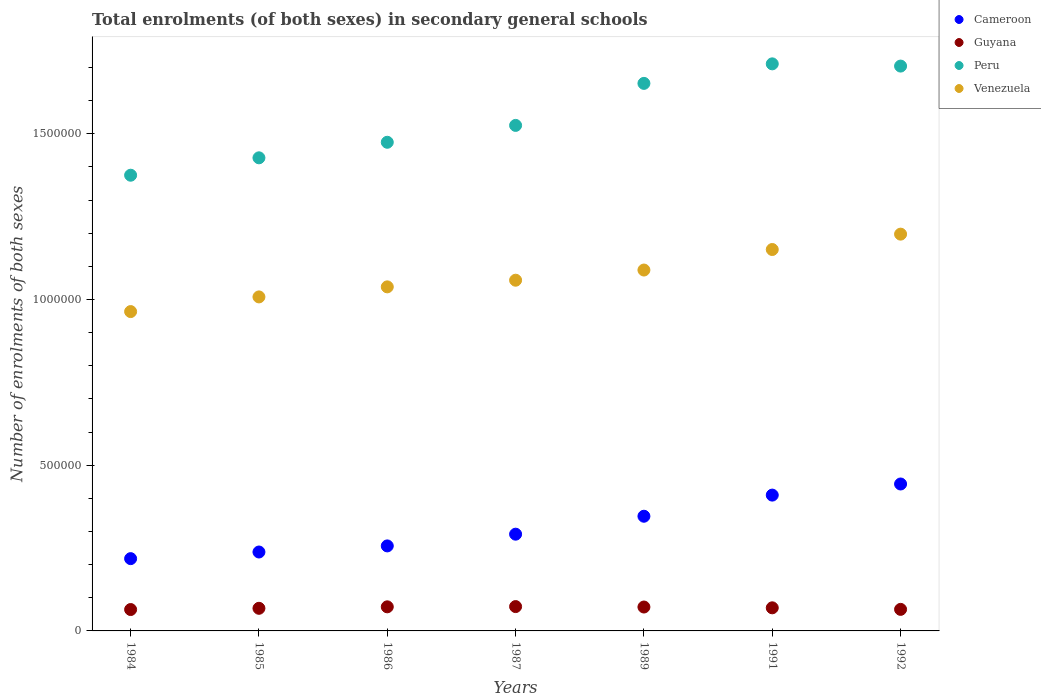What is the number of enrolments in secondary schools in Cameroon in 1989?
Keep it short and to the point. 3.46e+05. Across all years, what is the maximum number of enrolments in secondary schools in Cameroon?
Offer a very short reply. 4.43e+05. Across all years, what is the minimum number of enrolments in secondary schools in Venezuela?
Keep it short and to the point. 9.63e+05. In which year was the number of enrolments in secondary schools in Cameroon maximum?
Your response must be concise. 1992. What is the total number of enrolments in secondary schools in Guyana in the graph?
Your answer should be compact. 4.86e+05. What is the difference between the number of enrolments in secondary schools in Cameroon in 1985 and that in 1987?
Ensure brevity in your answer.  -5.38e+04. What is the difference between the number of enrolments in secondary schools in Cameroon in 1984 and the number of enrolments in secondary schools in Guyana in 1991?
Keep it short and to the point. 1.48e+05. What is the average number of enrolments in secondary schools in Peru per year?
Provide a succinct answer. 1.55e+06. In the year 1989, what is the difference between the number of enrolments in secondary schools in Peru and number of enrolments in secondary schools in Venezuela?
Offer a terse response. 5.63e+05. What is the ratio of the number of enrolments in secondary schools in Guyana in 1986 to that in 1987?
Ensure brevity in your answer.  0.99. Is the difference between the number of enrolments in secondary schools in Peru in 1987 and 1989 greater than the difference between the number of enrolments in secondary schools in Venezuela in 1987 and 1989?
Keep it short and to the point. No. What is the difference between the highest and the second highest number of enrolments in secondary schools in Guyana?
Your response must be concise. 739. What is the difference between the highest and the lowest number of enrolments in secondary schools in Peru?
Provide a succinct answer. 3.36e+05. In how many years, is the number of enrolments in secondary schools in Peru greater than the average number of enrolments in secondary schools in Peru taken over all years?
Keep it short and to the point. 3. Is the sum of the number of enrolments in secondary schools in Peru in 1987 and 1991 greater than the maximum number of enrolments in secondary schools in Venezuela across all years?
Your response must be concise. Yes. Is the number of enrolments in secondary schools in Cameroon strictly less than the number of enrolments in secondary schools in Guyana over the years?
Offer a terse response. No. How many dotlines are there?
Give a very brief answer. 4. How many years are there in the graph?
Your answer should be compact. 7. What is the difference between two consecutive major ticks on the Y-axis?
Make the answer very short. 5.00e+05. Are the values on the major ticks of Y-axis written in scientific E-notation?
Make the answer very short. No. Does the graph contain any zero values?
Provide a succinct answer. No. Does the graph contain grids?
Your answer should be compact. No. How many legend labels are there?
Offer a very short reply. 4. What is the title of the graph?
Keep it short and to the point. Total enrolments (of both sexes) in secondary general schools. Does "Marshall Islands" appear as one of the legend labels in the graph?
Keep it short and to the point. No. What is the label or title of the X-axis?
Make the answer very short. Years. What is the label or title of the Y-axis?
Your response must be concise. Number of enrolments of both sexes. What is the Number of enrolments of both sexes in Cameroon in 1984?
Make the answer very short. 2.18e+05. What is the Number of enrolments of both sexes in Guyana in 1984?
Your response must be concise. 6.45e+04. What is the Number of enrolments of both sexes in Peru in 1984?
Offer a very short reply. 1.37e+06. What is the Number of enrolments of both sexes of Venezuela in 1984?
Your answer should be compact. 9.63e+05. What is the Number of enrolments of both sexes in Cameroon in 1985?
Your response must be concise. 2.38e+05. What is the Number of enrolments of both sexes of Guyana in 1985?
Your answer should be very brief. 6.82e+04. What is the Number of enrolments of both sexes in Peru in 1985?
Your response must be concise. 1.43e+06. What is the Number of enrolments of both sexes of Venezuela in 1985?
Offer a very short reply. 1.01e+06. What is the Number of enrolments of both sexes in Cameroon in 1986?
Provide a succinct answer. 2.56e+05. What is the Number of enrolments of both sexes of Guyana in 1986?
Keep it short and to the point. 7.27e+04. What is the Number of enrolments of both sexes of Peru in 1986?
Your response must be concise. 1.47e+06. What is the Number of enrolments of both sexes of Venezuela in 1986?
Give a very brief answer. 1.04e+06. What is the Number of enrolments of both sexes in Cameroon in 1987?
Your answer should be compact. 2.92e+05. What is the Number of enrolments of both sexes of Guyana in 1987?
Your answer should be compact. 7.34e+04. What is the Number of enrolments of both sexes in Peru in 1987?
Provide a short and direct response. 1.53e+06. What is the Number of enrolments of both sexes of Venezuela in 1987?
Ensure brevity in your answer.  1.06e+06. What is the Number of enrolments of both sexes in Cameroon in 1989?
Provide a succinct answer. 3.46e+05. What is the Number of enrolments of both sexes of Guyana in 1989?
Ensure brevity in your answer.  7.21e+04. What is the Number of enrolments of both sexes in Peru in 1989?
Ensure brevity in your answer.  1.65e+06. What is the Number of enrolments of both sexes of Venezuela in 1989?
Offer a very short reply. 1.09e+06. What is the Number of enrolments of both sexes of Cameroon in 1991?
Provide a succinct answer. 4.10e+05. What is the Number of enrolments of both sexes of Guyana in 1991?
Keep it short and to the point. 6.97e+04. What is the Number of enrolments of both sexes in Peru in 1991?
Offer a very short reply. 1.71e+06. What is the Number of enrolments of both sexes in Venezuela in 1991?
Keep it short and to the point. 1.15e+06. What is the Number of enrolments of both sexes in Cameroon in 1992?
Keep it short and to the point. 4.43e+05. What is the Number of enrolments of both sexes in Guyana in 1992?
Your answer should be compact. 6.50e+04. What is the Number of enrolments of both sexes of Peru in 1992?
Make the answer very short. 1.70e+06. What is the Number of enrolments of both sexes of Venezuela in 1992?
Offer a terse response. 1.20e+06. Across all years, what is the maximum Number of enrolments of both sexes in Cameroon?
Give a very brief answer. 4.43e+05. Across all years, what is the maximum Number of enrolments of both sexes of Guyana?
Your answer should be very brief. 7.34e+04. Across all years, what is the maximum Number of enrolments of both sexes in Peru?
Your answer should be compact. 1.71e+06. Across all years, what is the maximum Number of enrolments of both sexes of Venezuela?
Your response must be concise. 1.20e+06. Across all years, what is the minimum Number of enrolments of both sexes of Cameroon?
Offer a terse response. 2.18e+05. Across all years, what is the minimum Number of enrolments of both sexes of Guyana?
Make the answer very short. 6.45e+04. Across all years, what is the minimum Number of enrolments of both sexes of Peru?
Give a very brief answer. 1.37e+06. Across all years, what is the minimum Number of enrolments of both sexes in Venezuela?
Provide a succinct answer. 9.63e+05. What is the total Number of enrolments of both sexes in Cameroon in the graph?
Offer a very short reply. 2.20e+06. What is the total Number of enrolments of both sexes in Guyana in the graph?
Your response must be concise. 4.86e+05. What is the total Number of enrolments of both sexes of Peru in the graph?
Provide a succinct answer. 1.09e+07. What is the total Number of enrolments of both sexes of Venezuela in the graph?
Give a very brief answer. 7.50e+06. What is the difference between the Number of enrolments of both sexes of Cameroon in 1984 and that in 1985?
Provide a succinct answer. -2.00e+04. What is the difference between the Number of enrolments of both sexes of Guyana in 1984 and that in 1985?
Provide a short and direct response. -3704. What is the difference between the Number of enrolments of both sexes in Peru in 1984 and that in 1985?
Ensure brevity in your answer.  -5.25e+04. What is the difference between the Number of enrolments of both sexes of Venezuela in 1984 and that in 1985?
Make the answer very short. -4.43e+04. What is the difference between the Number of enrolments of both sexes of Cameroon in 1984 and that in 1986?
Your answer should be compact. -3.84e+04. What is the difference between the Number of enrolments of both sexes of Guyana in 1984 and that in 1986?
Your answer should be very brief. -8161. What is the difference between the Number of enrolments of both sexes in Peru in 1984 and that in 1986?
Offer a very short reply. -9.94e+04. What is the difference between the Number of enrolments of both sexes of Venezuela in 1984 and that in 1986?
Your answer should be compact. -7.46e+04. What is the difference between the Number of enrolments of both sexes of Cameroon in 1984 and that in 1987?
Your answer should be very brief. -7.38e+04. What is the difference between the Number of enrolments of both sexes in Guyana in 1984 and that in 1987?
Your answer should be very brief. -8900. What is the difference between the Number of enrolments of both sexes of Peru in 1984 and that in 1987?
Your answer should be compact. -1.50e+05. What is the difference between the Number of enrolments of both sexes in Venezuela in 1984 and that in 1987?
Offer a terse response. -9.46e+04. What is the difference between the Number of enrolments of both sexes of Cameroon in 1984 and that in 1989?
Your response must be concise. -1.28e+05. What is the difference between the Number of enrolments of both sexes in Guyana in 1984 and that in 1989?
Ensure brevity in your answer.  -7578. What is the difference between the Number of enrolments of both sexes of Peru in 1984 and that in 1989?
Keep it short and to the point. -2.77e+05. What is the difference between the Number of enrolments of both sexes of Venezuela in 1984 and that in 1989?
Your response must be concise. -1.25e+05. What is the difference between the Number of enrolments of both sexes of Cameroon in 1984 and that in 1991?
Provide a succinct answer. -1.92e+05. What is the difference between the Number of enrolments of both sexes of Guyana in 1984 and that in 1991?
Make the answer very short. -5178. What is the difference between the Number of enrolments of both sexes in Peru in 1984 and that in 1991?
Give a very brief answer. -3.36e+05. What is the difference between the Number of enrolments of both sexes of Venezuela in 1984 and that in 1991?
Your answer should be compact. -1.87e+05. What is the difference between the Number of enrolments of both sexes in Cameroon in 1984 and that in 1992?
Keep it short and to the point. -2.25e+05. What is the difference between the Number of enrolments of both sexes in Guyana in 1984 and that in 1992?
Your answer should be compact. -511. What is the difference between the Number of enrolments of both sexes in Peru in 1984 and that in 1992?
Your response must be concise. -3.29e+05. What is the difference between the Number of enrolments of both sexes of Venezuela in 1984 and that in 1992?
Your response must be concise. -2.34e+05. What is the difference between the Number of enrolments of both sexes in Cameroon in 1985 and that in 1986?
Ensure brevity in your answer.  -1.84e+04. What is the difference between the Number of enrolments of both sexes in Guyana in 1985 and that in 1986?
Make the answer very short. -4457. What is the difference between the Number of enrolments of both sexes of Peru in 1985 and that in 1986?
Ensure brevity in your answer.  -4.69e+04. What is the difference between the Number of enrolments of both sexes in Venezuela in 1985 and that in 1986?
Your response must be concise. -3.03e+04. What is the difference between the Number of enrolments of both sexes in Cameroon in 1985 and that in 1987?
Your answer should be very brief. -5.38e+04. What is the difference between the Number of enrolments of both sexes of Guyana in 1985 and that in 1987?
Your response must be concise. -5196. What is the difference between the Number of enrolments of both sexes in Peru in 1985 and that in 1987?
Your answer should be compact. -9.78e+04. What is the difference between the Number of enrolments of both sexes of Venezuela in 1985 and that in 1987?
Offer a terse response. -5.04e+04. What is the difference between the Number of enrolments of both sexes in Cameroon in 1985 and that in 1989?
Provide a succinct answer. -1.08e+05. What is the difference between the Number of enrolments of both sexes in Guyana in 1985 and that in 1989?
Your response must be concise. -3874. What is the difference between the Number of enrolments of both sexes in Peru in 1985 and that in 1989?
Your response must be concise. -2.25e+05. What is the difference between the Number of enrolments of both sexes of Venezuela in 1985 and that in 1989?
Provide a short and direct response. -8.11e+04. What is the difference between the Number of enrolments of both sexes of Cameroon in 1985 and that in 1991?
Offer a terse response. -1.72e+05. What is the difference between the Number of enrolments of both sexes of Guyana in 1985 and that in 1991?
Provide a succinct answer. -1474. What is the difference between the Number of enrolments of both sexes in Peru in 1985 and that in 1991?
Your answer should be compact. -2.83e+05. What is the difference between the Number of enrolments of both sexes of Venezuela in 1985 and that in 1991?
Your answer should be compact. -1.43e+05. What is the difference between the Number of enrolments of both sexes in Cameroon in 1985 and that in 1992?
Offer a very short reply. -2.05e+05. What is the difference between the Number of enrolments of both sexes in Guyana in 1985 and that in 1992?
Offer a terse response. 3193. What is the difference between the Number of enrolments of both sexes of Peru in 1985 and that in 1992?
Provide a short and direct response. -2.77e+05. What is the difference between the Number of enrolments of both sexes of Venezuela in 1985 and that in 1992?
Give a very brief answer. -1.89e+05. What is the difference between the Number of enrolments of both sexes in Cameroon in 1986 and that in 1987?
Your answer should be very brief. -3.54e+04. What is the difference between the Number of enrolments of both sexes in Guyana in 1986 and that in 1987?
Your answer should be compact. -739. What is the difference between the Number of enrolments of both sexes of Peru in 1986 and that in 1987?
Your answer should be very brief. -5.09e+04. What is the difference between the Number of enrolments of both sexes in Venezuela in 1986 and that in 1987?
Your response must be concise. -2.01e+04. What is the difference between the Number of enrolments of both sexes of Cameroon in 1986 and that in 1989?
Offer a terse response. -8.95e+04. What is the difference between the Number of enrolments of both sexes in Guyana in 1986 and that in 1989?
Make the answer very short. 583. What is the difference between the Number of enrolments of both sexes in Peru in 1986 and that in 1989?
Make the answer very short. -1.78e+05. What is the difference between the Number of enrolments of both sexes of Venezuela in 1986 and that in 1989?
Give a very brief answer. -5.08e+04. What is the difference between the Number of enrolments of both sexes of Cameroon in 1986 and that in 1991?
Your response must be concise. -1.53e+05. What is the difference between the Number of enrolments of both sexes of Guyana in 1986 and that in 1991?
Offer a terse response. 2983. What is the difference between the Number of enrolments of both sexes in Peru in 1986 and that in 1991?
Your answer should be compact. -2.37e+05. What is the difference between the Number of enrolments of both sexes of Venezuela in 1986 and that in 1991?
Provide a succinct answer. -1.13e+05. What is the difference between the Number of enrolments of both sexes of Cameroon in 1986 and that in 1992?
Provide a succinct answer. -1.87e+05. What is the difference between the Number of enrolments of both sexes of Guyana in 1986 and that in 1992?
Make the answer very short. 7650. What is the difference between the Number of enrolments of both sexes of Peru in 1986 and that in 1992?
Your answer should be compact. -2.30e+05. What is the difference between the Number of enrolments of both sexes of Venezuela in 1986 and that in 1992?
Offer a terse response. -1.59e+05. What is the difference between the Number of enrolments of both sexes of Cameroon in 1987 and that in 1989?
Make the answer very short. -5.41e+04. What is the difference between the Number of enrolments of both sexes in Guyana in 1987 and that in 1989?
Provide a short and direct response. 1322. What is the difference between the Number of enrolments of both sexes of Peru in 1987 and that in 1989?
Keep it short and to the point. -1.27e+05. What is the difference between the Number of enrolments of both sexes in Venezuela in 1987 and that in 1989?
Your answer should be very brief. -3.07e+04. What is the difference between the Number of enrolments of both sexes in Cameroon in 1987 and that in 1991?
Give a very brief answer. -1.18e+05. What is the difference between the Number of enrolments of both sexes of Guyana in 1987 and that in 1991?
Make the answer very short. 3722. What is the difference between the Number of enrolments of both sexes in Peru in 1987 and that in 1991?
Your answer should be compact. -1.86e+05. What is the difference between the Number of enrolments of both sexes of Venezuela in 1987 and that in 1991?
Offer a very short reply. -9.26e+04. What is the difference between the Number of enrolments of both sexes of Cameroon in 1987 and that in 1992?
Provide a succinct answer. -1.51e+05. What is the difference between the Number of enrolments of both sexes of Guyana in 1987 and that in 1992?
Provide a short and direct response. 8389. What is the difference between the Number of enrolments of both sexes in Peru in 1987 and that in 1992?
Offer a terse response. -1.79e+05. What is the difference between the Number of enrolments of both sexes of Venezuela in 1987 and that in 1992?
Give a very brief answer. -1.39e+05. What is the difference between the Number of enrolments of both sexes in Cameroon in 1989 and that in 1991?
Your answer should be compact. -6.38e+04. What is the difference between the Number of enrolments of both sexes of Guyana in 1989 and that in 1991?
Offer a very short reply. 2400. What is the difference between the Number of enrolments of both sexes of Peru in 1989 and that in 1991?
Your answer should be very brief. -5.89e+04. What is the difference between the Number of enrolments of both sexes of Venezuela in 1989 and that in 1991?
Provide a succinct answer. -6.19e+04. What is the difference between the Number of enrolments of both sexes of Cameroon in 1989 and that in 1992?
Your answer should be compact. -9.73e+04. What is the difference between the Number of enrolments of both sexes of Guyana in 1989 and that in 1992?
Provide a succinct answer. 7067. What is the difference between the Number of enrolments of both sexes of Peru in 1989 and that in 1992?
Provide a short and direct response. -5.22e+04. What is the difference between the Number of enrolments of both sexes of Venezuela in 1989 and that in 1992?
Your answer should be compact. -1.08e+05. What is the difference between the Number of enrolments of both sexes in Cameroon in 1991 and that in 1992?
Ensure brevity in your answer.  -3.35e+04. What is the difference between the Number of enrolments of both sexes of Guyana in 1991 and that in 1992?
Give a very brief answer. 4667. What is the difference between the Number of enrolments of both sexes in Peru in 1991 and that in 1992?
Ensure brevity in your answer.  6718. What is the difference between the Number of enrolments of both sexes of Venezuela in 1991 and that in 1992?
Keep it short and to the point. -4.64e+04. What is the difference between the Number of enrolments of both sexes in Cameroon in 1984 and the Number of enrolments of both sexes in Guyana in 1985?
Make the answer very short. 1.50e+05. What is the difference between the Number of enrolments of both sexes in Cameroon in 1984 and the Number of enrolments of both sexes in Peru in 1985?
Ensure brevity in your answer.  -1.21e+06. What is the difference between the Number of enrolments of both sexes in Cameroon in 1984 and the Number of enrolments of both sexes in Venezuela in 1985?
Provide a succinct answer. -7.90e+05. What is the difference between the Number of enrolments of both sexes of Guyana in 1984 and the Number of enrolments of both sexes of Peru in 1985?
Offer a terse response. -1.36e+06. What is the difference between the Number of enrolments of both sexes of Guyana in 1984 and the Number of enrolments of both sexes of Venezuela in 1985?
Ensure brevity in your answer.  -9.43e+05. What is the difference between the Number of enrolments of both sexes of Peru in 1984 and the Number of enrolments of both sexes of Venezuela in 1985?
Your answer should be very brief. 3.67e+05. What is the difference between the Number of enrolments of both sexes of Cameroon in 1984 and the Number of enrolments of both sexes of Guyana in 1986?
Provide a succinct answer. 1.45e+05. What is the difference between the Number of enrolments of both sexes in Cameroon in 1984 and the Number of enrolments of both sexes in Peru in 1986?
Your answer should be very brief. -1.26e+06. What is the difference between the Number of enrolments of both sexes in Cameroon in 1984 and the Number of enrolments of both sexes in Venezuela in 1986?
Keep it short and to the point. -8.20e+05. What is the difference between the Number of enrolments of both sexes in Guyana in 1984 and the Number of enrolments of both sexes in Peru in 1986?
Your answer should be compact. -1.41e+06. What is the difference between the Number of enrolments of both sexes of Guyana in 1984 and the Number of enrolments of both sexes of Venezuela in 1986?
Your response must be concise. -9.73e+05. What is the difference between the Number of enrolments of both sexes in Peru in 1984 and the Number of enrolments of both sexes in Venezuela in 1986?
Offer a terse response. 3.37e+05. What is the difference between the Number of enrolments of both sexes in Cameroon in 1984 and the Number of enrolments of both sexes in Guyana in 1987?
Give a very brief answer. 1.45e+05. What is the difference between the Number of enrolments of both sexes in Cameroon in 1984 and the Number of enrolments of both sexes in Peru in 1987?
Ensure brevity in your answer.  -1.31e+06. What is the difference between the Number of enrolments of both sexes in Cameroon in 1984 and the Number of enrolments of both sexes in Venezuela in 1987?
Give a very brief answer. -8.40e+05. What is the difference between the Number of enrolments of both sexes of Guyana in 1984 and the Number of enrolments of both sexes of Peru in 1987?
Offer a terse response. -1.46e+06. What is the difference between the Number of enrolments of both sexes in Guyana in 1984 and the Number of enrolments of both sexes in Venezuela in 1987?
Ensure brevity in your answer.  -9.93e+05. What is the difference between the Number of enrolments of both sexes of Peru in 1984 and the Number of enrolments of both sexes of Venezuela in 1987?
Make the answer very short. 3.17e+05. What is the difference between the Number of enrolments of both sexes of Cameroon in 1984 and the Number of enrolments of both sexes of Guyana in 1989?
Provide a succinct answer. 1.46e+05. What is the difference between the Number of enrolments of both sexes in Cameroon in 1984 and the Number of enrolments of both sexes in Peru in 1989?
Ensure brevity in your answer.  -1.43e+06. What is the difference between the Number of enrolments of both sexes in Cameroon in 1984 and the Number of enrolments of both sexes in Venezuela in 1989?
Provide a succinct answer. -8.71e+05. What is the difference between the Number of enrolments of both sexes of Guyana in 1984 and the Number of enrolments of both sexes of Peru in 1989?
Offer a very short reply. -1.59e+06. What is the difference between the Number of enrolments of both sexes of Guyana in 1984 and the Number of enrolments of both sexes of Venezuela in 1989?
Provide a short and direct response. -1.02e+06. What is the difference between the Number of enrolments of both sexes in Peru in 1984 and the Number of enrolments of both sexes in Venezuela in 1989?
Make the answer very short. 2.86e+05. What is the difference between the Number of enrolments of both sexes of Cameroon in 1984 and the Number of enrolments of both sexes of Guyana in 1991?
Give a very brief answer. 1.48e+05. What is the difference between the Number of enrolments of both sexes in Cameroon in 1984 and the Number of enrolments of both sexes in Peru in 1991?
Provide a succinct answer. -1.49e+06. What is the difference between the Number of enrolments of both sexes of Cameroon in 1984 and the Number of enrolments of both sexes of Venezuela in 1991?
Your answer should be compact. -9.33e+05. What is the difference between the Number of enrolments of both sexes of Guyana in 1984 and the Number of enrolments of both sexes of Peru in 1991?
Give a very brief answer. -1.65e+06. What is the difference between the Number of enrolments of both sexes of Guyana in 1984 and the Number of enrolments of both sexes of Venezuela in 1991?
Offer a very short reply. -1.09e+06. What is the difference between the Number of enrolments of both sexes of Peru in 1984 and the Number of enrolments of both sexes of Venezuela in 1991?
Your response must be concise. 2.24e+05. What is the difference between the Number of enrolments of both sexes in Cameroon in 1984 and the Number of enrolments of both sexes in Guyana in 1992?
Ensure brevity in your answer.  1.53e+05. What is the difference between the Number of enrolments of both sexes of Cameroon in 1984 and the Number of enrolments of both sexes of Peru in 1992?
Your answer should be compact. -1.49e+06. What is the difference between the Number of enrolments of both sexes in Cameroon in 1984 and the Number of enrolments of both sexes in Venezuela in 1992?
Your answer should be compact. -9.79e+05. What is the difference between the Number of enrolments of both sexes in Guyana in 1984 and the Number of enrolments of both sexes in Peru in 1992?
Ensure brevity in your answer.  -1.64e+06. What is the difference between the Number of enrolments of both sexes of Guyana in 1984 and the Number of enrolments of both sexes of Venezuela in 1992?
Make the answer very short. -1.13e+06. What is the difference between the Number of enrolments of both sexes of Peru in 1984 and the Number of enrolments of both sexes of Venezuela in 1992?
Give a very brief answer. 1.78e+05. What is the difference between the Number of enrolments of both sexes in Cameroon in 1985 and the Number of enrolments of both sexes in Guyana in 1986?
Your response must be concise. 1.65e+05. What is the difference between the Number of enrolments of both sexes in Cameroon in 1985 and the Number of enrolments of both sexes in Peru in 1986?
Your answer should be compact. -1.24e+06. What is the difference between the Number of enrolments of both sexes in Cameroon in 1985 and the Number of enrolments of both sexes in Venezuela in 1986?
Provide a short and direct response. -8.00e+05. What is the difference between the Number of enrolments of both sexes of Guyana in 1985 and the Number of enrolments of both sexes of Peru in 1986?
Ensure brevity in your answer.  -1.41e+06. What is the difference between the Number of enrolments of both sexes in Guyana in 1985 and the Number of enrolments of both sexes in Venezuela in 1986?
Keep it short and to the point. -9.70e+05. What is the difference between the Number of enrolments of both sexes in Peru in 1985 and the Number of enrolments of both sexes in Venezuela in 1986?
Keep it short and to the point. 3.89e+05. What is the difference between the Number of enrolments of both sexes of Cameroon in 1985 and the Number of enrolments of both sexes of Guyana in 1987?
Provide a succinct answer. 1.65e+05. What is the difference between the Number of enrolments of both sexes in Cameroon in 1985 and the Number of enrolments of both sexes in Peru in 1987?
Your answer should be compact. -1.29e+06. What is the difference between the Number of enrolments of both sexes of Cameroon in 1985 and the Number of enrolments of both sexes of Venezuela in 1987?
Offer a very short reply. -8.20e+05. What is the difference between the Number of enrolments of both sexes in Guyana in 1985 and the Number of enrolments of both sexes in Peru in 1987?
Provide a short and direct response. -1.46e+06. What is the difference between the Number of enrolments of both sexes of Guyana in 1985 and the Number of enrolments of both sexes of Venezuela in 1987?
Keep it short and to the point. -9.90e+05. What is the difference between the Number of enrolments of both sexes in Peru in 1985 and the Number of enrolments of both sexes in Venezuela in 1987?
Ensure brevity in your answer.  3.69e+05. What is the difference between the Number of enrolments of both sexes of Cameroon in 1985 and the Number of enrolments of both sexes of Guyana in 1989?
Offer a terse response. 1.66e+05. What is the difference between the Number of enrolments of both sexes in Cameroon in 1985 and the Number of enrolments of both sexes in Peru in 1989?
Offer a very short reply. -1.41e+06. What is the difference between the Number of enrolments of both sexes in Cameroon in 1985 and the Number of enrolments of both sexes in Venezuela in 1989?
Give a very brief answer. -8.51e+05. What is the difference between the Number of enrolments of both sexes in Guyana in 1985 and the Number of enrolments of both sexes in Peru in 1989?
Offer a terse response. -1.58e+06. What is the difference between the Number of enrolments of both sexes in Guyana in 1985 and the Number of enrolments of both sexes in Venezuela in 1989?
Your response must be concise. -1.02e+06. What is the difference between the Number of enrolments of both sexes of Peru in 1985 and the Number of enrolments of both sexes of Venezuela in 1989?
Provide a short and direct response. 3.39e+05. What is the difference between the Number of enrolments of both sexes in Cameroon in 1985 and the Number of enrolments of both sexes in Guyana in 1991?
Give a very brief answer. 1.68e+05. What is the difference between the Number of enrolments of both sexes in Cameroon in 1985 and the Number of enrolments of both sexes in Peru in 1991?
Offer a terse response. -1.47e+06. What is the difference between the Number of enrolments of both sexes in Cameroon in 1985 and the Number of enrolments of both sexes in Venezuela in 1991?
Your answer should be very brief. -9.13e+05. What is the difference between the Number of enrolments of both sexes of Guyana in 1985 and the Number of enrolments of both sexes of Peru in 1991?
Provide a short and direct response. -1.64e+06. What is the difference between the Number of enrolments of both sexes of Guyana in 1985 and the Number of enrolments of both sexes of Venezuela in 1991?
Your response must be concise. -1.08e+06. What is the difference between the Number of enrolments of both sexes in Peru in 1985 and the Number of enrolments of both sexes in Venezuela in 1991?
Make the answer very short. 2.77e+05. What is the difference between the Number of enrolments of both sexes of Cameroon in 1985 and the Number of enrolments of both sexes of Guyana in 1992?
Your answer should be very brief. 1.73e+05. What is the difference between the Number of enrolments of both sexes of Cameroon in 1985 and the Number of enrolments of both sexes of Peru in 1992?
Provide a succinct answer. -1.47e+06. What is the difference between the Number of enrolments of both sexes in Cameroon in 1985 and the Number of enrolments of both sexes in Venezuela in 1992?
Keep it short and to the point. -9.59e+05. What is the difference between the Number of enrolments of both sexes of Guyana in 1985 and the Number of enrolments of both sexes of Peru in 1992?
Provide a succinct answer. -1.64e+06. What is the difference between the Number of enrolments of both sexes of Guyana in 1985 and the Number of enrolments of both sexes of Venezuela in 1992?
Your response must be concise. -1.13e+06. What is the difference between the Number of enrolments of both sexes in Peru in 1985 and the Number of enrolments of both sexes in Venezuela in 1992?
Your answer should be compact. 2.30e+05. What is the difference between the Number of enrolments of both sexes of Cameroon in 1986 and the Number of enrolments of both sexes of Guyana in 1987?
Your response must be concise. 1.83e+05. What is the difference between the Number of enrolments of both sexes in Cameroon in 1986 and the Number of enrolments of both sexes in Peru in 1987?
Provide a succinct answer. -1.27e+06. What is the difference between the Number of enrolments of both sexes in Cameroon in 1986 and the Number of enrolments of both sexes in Venezuela in 1987?
Your answer should be very brief. -8.02e+05. What is the difference between the Number of enrolments of both sexes of Guyana in 1986 and the Number of enrolments of both sexes of Peru in 1987?
Your response must be concise. -1.45e+06. What is the difference between the Number of enrolments of both sexes of Guyana in 1986 and the Number of enrolments of both sexes of Venezuela in 1987?
Make the answer very short. -9.85e+05. What is the difference between the Number of enrolments of both sexes in Peru in 1986 and the Number of enrolments of both sexes in Venezuela in 1987?
Give a very brief answer. 4.16e+05. What is the difference between the Number of enrolments of both sexes in Cameroon in 1986 and the Number of enrolments of both sexes in Guyana in 1989?
Your response must be concise. 1.84e+05. What is the difference between the Number of enrolments of both sexes in Cameroon in 1986 and the Number of enrolments of both sexes in Peru in 1989?
Ensure brevity in your answer.  -1.40e+06. What is the difference between the Number of enrolments of both sexes of Cameroon in 1986 and the Number of enrolments of both sexes of Venezuela in 1989?
Keep it short and to the point. -8.32e+05. What is the difference between the Number of enrolments of both sexes of Guyana in 1986 and the Number of enrolments of both sexes of Peru in 1989?
Offer a terse response. -1.58e+06. What is the difference between the Number of enrolments of both sexes in Guyana in 1986 and the Number of enrolments of both sexes in Venezuela in 1989?
Make the answer very short. -1.02e+06. What is the difference between the Number of enrolments of both sexes in Peru in 1986 and the Number of enrolments of both sexes in Venezuela in 1989?
Make the answer very short. 3.85e+05. What is the difference between the Number of enrolments of both sexes in Cameroon in 1986 and the Number of enrolments of both sexes in Guyana in 1991?
Your response must be concise. 1.87e+05. What is the difference between the Number of enrolments of both sexes in Cameroon in 1986 and the Number of enrolments of both sexes in Peru in 1991?
Ensure brevity in your answer.  -1.45e+06. What is the difference between the Number of enrolments of both sexes of Cameroon in 1986 and the Number of enrolments of both sexes of Venezuela in 1991?
Your answer should be very brief. -8.94e+05. What is the difference between the Number of enrolments of both sexes in Guyana in 1986 and the Number of enrolments of both sexes in Peru in 1991?
Provide a succinct answer. -1.64e+06. What is the difference between the Number of enrolments of both sexes of Guyana in 1986 and the Number of enrolments of both sexes of Venezuela in 1991?
Keep it short and to the point. -1.08e+06. What is the difference between the Number of enrolments of both sexes of Peru in 1986 and the Number of enrolments of both sexes of Venezuela in 1991?
Offer a very short reply. 3.24e+05. What is the difference between the Number of enrolments of both sexes in Cameroon in 1986 and the Number of enrolments of both sexes in Guyana in 1992?
Keep it short and to the point. 1.91e+05. What is the difference between the Number of enrolments of both sexes in Cameroon in 1986 and the Number of enrolments of both sexes in Peru in 1992?
Offer a terse response. -1.45e+06. What is the difference between the Number of enrolments of both sexes of Cameroon in 1986 and the Number of enrolments of both sexes of Venezuela in 1992?
Make the answer very short. -9.41e+05. What is the difference between the Number of enrolments of both sexes of Guyana in 1986 and the Number of enrolments of both sexes of Peru in 1992?
Your answer should be compact. -1.63e+06. What is the difference between the Number of enrolments of both sexes in Guyana in 1986 and the Number of enrolments of both sexes in Venezuela in 1992?
Your answer should be compact. -1.12e+06. What is the difference between the Number of enrolments of both sexes in Peru in 1986 and the Number of enrolments of both sexes in Venezuela in 1992?
Your response must be concise. 2.77e+05. What is the difference between the Number of enrolments of both sexes of Cameroon in 1987 and the Number of enrolments of both sexes of Guyana in 1989?
Your answer should be very brief. 2.20e+05. What is the difference between the Number of enrolments of both sexes in Cameroon in 1987 and the Number of enrolments of both sexes in Peru in 1989?
Provide a succinct answer. -1.36e+06. What is the difference between the Number of enrolments of both sexes of Cameroon in 1987 and the Number of enrolments of both sexes of Venezuela in 1989?
Offer a terse response. -7.97e+05. What is the difference between the Number of enrolments of both sexes of Guyana in 1987 and the Number of enrolments of both sexes of Peru in 1989?
Provide a short and direct response. -1.58e+06. What is the difference between the Number of enrolments of both sexes of Guyana in 1987 and the Number of enrolments of both sexes of Venezuela in 1989?
Your answer should be compact. -1.02e+06. What is the difference between the Number of enrolments of both sexes of Peru in 1987 and the Number of enrolments of both sexes of Venezuela in 1989?
Give a very brief answer. 4.36e+05. What is the difference between the Number of enrolments of both sexes in Cameroon in 1987 and the Number of enrolments of both sexes in Guyana in 1991?
Your response must be concise. 2.22e+05. What is the difference between the Number of enrolments of both sexes of Cameroon in 1987 and the Number of enrolments of both sexes of Peru in 1991?
Offer a terse response. -1.42e+06. What is the difference between the Number of enrolments of both sexes of Cameroon in 1987 and the Number of enrolments of both sexes of Venezuela in 1991?
Your answer should be very brief. -8.59e+05. What is the difference between the Number of enrolments of both sexes in Guyana in 1987 and the Number of enrolments of both sexes in Peru in 1991?
Offer a terse response. -1.64e+06. What is the difference between the Number of enrolments of both sexes of Guyana in 1987 and the Number of enrolments of both sexes of Venezuela in 1991?
Make the answer very short. -1.08e+06. What is the difference between the Number of enrolments of both sexes in Peru in 1987 and the Number of enrolments of both sexes in Venezuela in 1991?
Ensure brevity in your answer.  3.74e+05. What is the difference between the Number of enrolments of both sexes of Cameroon in 1987 and the Number of enrolments of both sexes of Guyana in 1992?
Ensure brevity in your answer.  2.27e+05. What is the difference between the Number of enrolments of both sexes of Cameroon in 1987 and the Number of enrolments of both sexes of Peru in 1992?
Your response must be concise. -1.41e+06. What is the difference between the Number of enrolments of both sexes in Cameroon in 1987 and the Number of enrolments of both sexes in Venezuela in 1992?
Make the answer very short. -9.05e+05. What is the difference between the Number of enrolments of both sexes in Guyana in 1987 and the Number of enrolments of both sexes in Peru in 1992?
Your answer should be very brief. -1.63e+06. What is the difference between the Number of enrolments of both sexes in Guyana in 1987 and the Number of enrolments of both sexes in Venezuela in 1992?
Give a very brief answer. -1.12e+06. What is the difference between the Number of enrolments of both sexes in Peru in 1987 and the Number of enrolments of both sexes in Venezuela in 1992?
Your answer should be very brief. 3.28e+05. What is the difference between the Number of enrolments of both sexes in Cameroon in 1989 and the Number of enrolments of both sexes in Guyana in 1991?
Make the answer very short. 2.76e+05. What is the difference between the Number of enrolments of both sexes in Cameroon in 1989 and the Number of enrolments of both sexes in Peru in 1991?
Offer a terse response. -1.36e+06. What is the difference between the Number of enrolments of both sexes of Cameroon in 1989 and the Number of enrolments of both sexes of Venezuela in 1991?
Provide a short and direct response. -8.05e+05. What is the difference between the Number of enrolments of both sexes in Guyana in 1989 and the Number of enrolments of both sexes in Peru in 1991?
Make the answer very short. -1.64e+06. What is the difference between the Number of enrolments of both sexes of Guyana in 1989 and the Number of enrolments of both sexes of Venezuela in 1991?
Your answer should be compact. -1.08e+06. What is the difference between the Number of enrolments of both sexes in Peru in 1989 and the Number of enrolments of both sexes in Venezuela in 1991?
Your answer should be compact. 5.01e+05. What is the difference between the Number of enrolments of both sexes in Cameroon in 1989 and the Number of enrolments of both sexes in Guyana in 1992?
Ensure brevity in your answer.  2.81e+05. What is the difference between the Number of enrolments of both sexes in Cameroon in 1989 and the Number of enrolments of both sexes in Peru in 1992?
Give a very brief answer. -1.36e+06. What is the difference between the Number of enrolments of both sexes in Cameroon in 1989 and the Number of enrolments of both sexes in Venezuela in 1992?
Provide a succinct answer. -8.51e+05. What is the difference between the Number of enrolments of both sexes of Guyana in 1989 and the Number of enrolments of both sexes of Peru in 1992?
Offer a terse response. -1.63e+06. What is the difference between the Number of enrolments of both sexes in Guyana in 1989 and the Number of enrolments of both sexes in Venezuela in 1992?
Offer a terse response. -1.12e+06. What is the difference between the Number of enrolments of both sexes in Peru in 1989 and the Number of enrolments of both sexes in Venezuela in 1992?
Your response must be concise. 4.55e+05. What is the difference between the Number of enrolments of both sexes of Cameroon in 1991 and the Number of enrolments of both sexes of Guyana in 1992?
Give a very brief answer. 3.45e+05. What is the difference between the Number of enrolments of both sexes of Cameroon in 1991 and the Number of enrolments of both sexes of Peru in 1992?
Your response must be concise. -1.29e+06. What is the difference between the Number of enrolments of both sexes of Cameroon in 1991 and the Number of enrolments of both sexes of Venezuela in 1992?
Make the answer very short. -7.87e+05. What is the difference between the Number of enrolments of both sexes in Guyana in 1991 and the Number of enrolments of both sexes in Peru in 1992?
Give a very brief answer. -1.63e+06. What is the difference between the Number of enrolments of both sexes in Guyana in 1991 and the Number of enrolments of both sexes in Venezuela in 1992?
Your response must be concise. -1.13e+06. What is the difference between the Number of enrolments of both sexes of Peru in 1991 and the Number of enrolments of both sexes of Venezuela in 1992?
Provide a short and direct response. 5.14e+05. What is the average Number of enrolments of both sexes in Cameroon per year?
Offer a very short reply. 3.15e+05. What is the average Number of enrolments of both sexes in Guyana per year?
Provide a succinct answer. 6.94e+04. What is the average Number of enrolments of both sexes of Peru per year?
Provide a succinct answer. 1.55e+06. What is the average Number of enrolments of both sexes in Venezuela per year?
Offer a terse response. 1.07e+06. In the year 1984, what is the difference between the Number of enrolments of both sexes in Cameroon and Number of enrolments of both sexes in Guyana?
Provide a succinct answer. 1.54e+05. In the year 1984, what is the difference between the Number of enrolments of both sexes in Cameroon and Number of enrolments of both sexes in Peru?
Your answer should be very brief. -1.16e+06. In the year 1984, what is the difference between the Number of enrolments of both sexes in Cameroon and Number of enrolments of both sexes in Venezuela?
Give a very brief answer. -7.45e+05. In the year 1984, what is the difference between the Number of enrolments of both sexes in Guyana and Number of enrolments of both sexes in Peru?
Provide a succinct answer. -1.31e+06. In the year 1984, what is the difference between the Number of enrolments of both sexes of Guyana and Number of enrolments of both sexes of Venezuela?
Ensure brevity in your answer.  -8.99e+05. In the year 1984, what is the difference between the Number of enrolments of both sexes in Peru and Number of enrolments of both sexes in Venezuela?
Offer a very short reply. 4.11e+05. In the year 1985, what is the difference between the Number of enrolments of both sexes of Cameroon and Number of enrolments of both sexes of Guyana?
Your response must be concise. 1.70e+05. In the year 1985, what is the difference between the Number of enrolments of both sexes in Cameroon and Number of enrolments of both sexes in Peru?
Provide a succinct answer. -1.19e+06. In the year 1985, what is the difference between the Number of enrolments of both sexes of Cameroon and Number of enrolments of both sexes of Venezuela?
Offer a terse response. -7.70e+05. In the year 1985, what is the difference between the Number of enrolments of both sexes in Guyana and Number of enrolments of both sexes in Peru?
Make the answer very short. -1.36e+06. In the year 1985, what is the difference between the Number of enrolments of both sexes in Guyana and Number of enrolments of both sexes in Venezuela?
Your response must be concise. -9.39e+05. In the year 1985, what is the difference between the Number of enrolments of both sexes of Peru and Number of enrolments of both sexes of Venezuela?
Your answer should be compact. 4.20e+05. In the year 1986, what is the difference between the Number of enrolments of both sexes of Cameroon and Number of enrolments of both sexes of Guyana?
Ensure brevity in your answer.  1.84e+05. In the year 1986, what is the difference between the Number of enrolments of both sexes in Cameroon and Number of enrolments of both sexes in Peru?
Your answer should be very brief. -1.22e+06. In the year 1986, what is the difference between the Number of enrolments of both sexes of Cameroon and Number of enrolments of both sexes of Venezuela?
Offer a terse response. -7.81e+05. In the year 1986, what is the difference between the Number of enrolments of both sexes of Guyana and Number of enrolments of both sexes of Peru?
Make the answer very short. -1.40e+06. In the year 1986, what is the difference between the Number of enrolments of both sexes of Guyana and Number of enrolments of both sexes of Venezuela?
Make the answer very short. -9.65e+05. In the year 1986, what is the difference between the Number of enrolments of both sexes of Peru and Number of enrolments of both sexes of Venezuela?
Provide a succinct answer. 4.36e+05. In the year 1987, what is the difference between the Number of enrolments of both sexes in Cameroon and Number of enrolments of both sexes in Guyana?
Provide a short and direct response. 2.18e+05. In the year 1987, what is the difference between the Number of enrolments of both sexes of Cameroon and Number of enrolments of both sexes of Peru?
Make the answer very short. -1.23e+06. In the year 1987, what is the difference between the Number of enrolments of both sexes of Cameroon and Number of enrolments of both sexes of Venezuela?
Give a very brief answer. -7.66e+05. In the year 1987, what is the difference between the Number of enrolments of both sexes of Guyana and Number of enrolments of both sexes of Peru?
Provide a succinct answer. -1.45e+06. In the year 1987, what is the difference between the Number of enrolments of both sexes in Guyana and Number of enrolments of both sexes in Venezuela?
Offer a terse response. -9.85e+05. In the year 1987, what is the difference between the Number of enrolments of both sexes in Peru and Number of enrolments of both sexes in Venezuela?
Your response must be concise. 4.67e+05. In the year 1989, what is the difference between the Number of enrolments of both sexes in Cameroon and Number of enrolments of both sexes in Guyana?
Ensure brevity in your answer.  2.74e+05. In the year 1989, what is the difference between the Number of enrolments of both sexes of Cameroon and Number of enrolments of both sexes of Peru?
Ensure brevity in your answer.  -1.31e+06. In the year 1989, what is the difference between the Number of enrolments of both sexes in Cameroon and Number of enrolments of both sexes in Venezuela?
Offer a very short reply. -7.43e+05. In the year 1989, what is the difference between the Number of enrolments of both sexes of Guyana and Number of enrolments of both sexes of Peru?
Your response must be concise. -1.58e+06. In the year 1989, what is the difference between the Number of enrolments of both sexes of Guyana and Number of enrolments of both sexes of Venezuela?
Provide a short and direct response. -1.02e+06. In the year 1989, what is the difference between the Number of enrolments of both sexes of Peru and Number of enrolments of both sexes of Venezuela?
Offer a terse response. 5.63e+05. In the year 1991, what is the difference between the Number of enrolments of both sexes of Cameroon and Number of enrolments of both sexes of Guyana?
Keep it short and to the point. 3.40e+05. In the year 1991, what is the difference between the Number of enrolments of both sexes in Cameroon and Number of enrolments of both sexes in Peru?
Ensure brevity in your answer.  -1.30e+06. In the year 1991, what is the difference between the Number of enrolments of both sexes of Cameroon and Number of enrolments of both sexes of Venezuela?
Your response must be concise. -7.41e+05. In the year 1991, what is the difference between the Number of enrolments of both sexes of Guyana and Number of enrolments of both sexes of Peru?
Make the answer very short. -1.64e+06. In the year 1991, what is the difference between the Number of enrolments of both sexes of Guyana and Number of enrolments of both sexes of Venezuela?
Keep it short and to the point. -1.08e+06. In the year 1991, what is the difference between the Number of enrolments of both sexes in Peru and Number of enrolments of both sexes in Venezuela?
Your answer should be compact. 5.60e+05. In the year 1992, what is the difference between the Number of enrolments of both sexes of Cameroon and Number of enrolments of both sexes of Guyana?
Your answer should be compact. 3.78e+05. In the year 1992, what is the difference between the Number of enrolments of both sexes of Cameroon and Number of enrolments of both sexes of Peru?
Give a very brief answer. -1.26e+06. In the year 1992, what is the difference between the Number of enrolments of both sexes in Cameroon and Number of enrolments of both sexes in Venezuela?
Offer a terse response. -7.54e+05. In the year 1992, what is the difference between the Number of enrolments of both sexes in Guyana and Number of enrolments of both sexes in Peru?
Your answer should be compact. -1.64e+06. In the year 1992, what is the difference between the Number of enrolments of both sexes of Guyana and Number of enrolments of both sexes of Venezuela?
Give a very brief answer. -1.13e+06. In the year 1992, what is the difference between the Number of enrolments of both sexes in Peru and Number of enrolments of both sexes in Venezuela?
Your answer should be very brief. 5.07e+05. What is the ratio of the Number of enrolments of both sexes of Cameroon in 1984 to that in 1985?
Ensure brevity in your answer.  0.92. What is the ratio of the Number of enrolments of both sexes of Guyana in 1984 to that in 1985?
Offer a terse response. 0.95. What is the ratio of the Number of enrolments of both sexes of Peru in 1984 to that in 1985?
Offer a very short reply. 0.96. What is the ratio of the Number of enrolments of both sexes in Venezuela in 1984 to that in 1985?
Your answer should be compact. 0.96. What is the ratio of the Number of enrolments of both sexes of Cameroon in 1984 to that in 1986?
Your answer should be very brief. 0.85. What is the ratio of the Number of enrolments of both sexes of Guyana in 1984 to that in 1986?
Offer a terse response. 0.89. What is the ratio of the Number of enrolments of both sexes in Peru in 1984 to that in 1986?
Your answer should be very brief. 0.93. What is the ratio of the Number of enrolments of both sexes in Venezuela in 1984 to that in 1986?
Your answer should be very brief. 0.93. What is the ratio of the Number of enrolments of both sexes in Cameroon in 1984 to that in 1987?
Offer a terse response. 0.75. What is the ratio of the Number of enrolments of both sexes in Guyana in 1984 to that in 1987?
Your answer should be very brief. 0.88. What is the ratio of the Number of enrolments of both sexes in Peru in 1984 to that in 1987?
Your answer should be very brief. 0.9. What is the ratio of the Number of enrolments of both sexes in Venezuela in 1984 to that in 1987?
Keep it short and to the point. 0.91. What is the ratio of the Number of enrolments of both sexes of Cameroon in 1984 to that in 1989?
Offer a terse response. 0.63. What is the ratio of the Number of enrolments of both sexes of Guyana in 1984 to that in 1989?
Keep it short and to the point. 0.89. What is the ratio of the Number of enrolments of both sexes of Peru in 1984 to that in 1989?
Your answer should be compact. 0.83. What is the ratio of the Number of enrolments of both sexes of Venezuela in 1984 to that in 1989?
Keep it short and to the point. 0.88. What is the ratio of the Number of enrolments of both sexes of Cameroon in 1984 to that in 1991?
Provide a short and direct response. 0.53. What is the ratio of the Number of enrolments of both sexes in Guyana in 1984 to that in 1991?
Provide a succinct answer. 0.93. What is the ratio of the Number of enrolments of both sexes of Peru in 1984 to that in 1991?
Your answer should be compact. 0.8. What is the ratio of the Number of enrolments of both sexes of Venezuela in 1984 to that in 1991?
Make the answer very short. 0.84. What is the ratio of the Number of enrolments of both sexes in Cameroon in 1984 to that in 1992?
Provide a succinct answer. 0.49. What is the ratio of the Number of enrolments of both sexes of Guyana in 1984 to that in 1992?
Offer a terse response. 0.99. What is the ratio of the Number of enrolments of both sexes of Peru in 1984 to that in 1992?
Make the answer very short. 0.81. What is the ratio of the Number of enrolments of both sexes of Venezuela in 1984 to that in 1992?
Your response must be concise. 0.8. What is the ratio of the Number of enrolments of both sexes of Cameroon in 1985 to that in 1986?
Your answer should be compact. 0.93. What is the ratio of the Number of enrolments of both sexes in Guyana in 1985 to that in 1986?
Offer a very short reply. 0.94. What is the ratio of the Number of enrolments of both sexes in Peru in 1985 to that in 1986?
Give a very brief answer. 0.97. What is the ratio of the Number of enrolments of both sexes of Venezuela in 1985 to that in 1986?
Ensure brevity in your answer.  0.97. What is the ratio of the Number of enrolments of both sexes in Cameroon in 1985 to that in 1987?
Offer a very short reply. 0.82. What is the ratio of the Number of enrolments of both sexes of Guyana in 1985 to that in 1987?
Offer a very short reply. 0.93. What is the ratio of the Number of enrolments of both sexes of Peru in 1985 to that in 1987?
Keep it short and to the point. 0.94. What is the ratio of the Number of enrolments of both sexes in Cameroon in 1985 to that in 1989?
Make the answer very short. 0.69. What is the ratio of the Number of enrolments of both sexes in Guyana in 1985 to that in 1989?
Offer a terse response. 0.95. What is the ratio of the Number of enrolments of both sexes of Peru in 1985 to that in 1989?
Give a very brief answer. 0.86. What is the ratio of the Number of enrolments of both sexes in Venezuela in 1985 to that in 1989?
Offer a terse response. 0.93. What is the ratio of the Number of enrolments of both sexes in Cameroon in 1985 to that in 1991?
Offer a very short reply. 0.58. What is the ratio of the Number of enrolments of both sexes of Guyana in 1985 to that in 1991?
Provide a short and direct response. 0.98. What is the ratio of the Number of enrolments of both sexes in Peru in 1985 to that in 1991?
Make the answer very short. 0.83. What is the ratio of the Number of enrolments of both sexes in Venezuela in 1985 to that in 1991?
Your answer should be compact. 0.88. What is the ratio of the Number of enrolments of both sexes of Cameroon in 1985 to that in 1992?
Provide a short and direct response. 0.54. What is the ratio of the Number of enrolments of both sexes in Guyana in 1985 to that in 1992?
Provide a short and direct response. 1.05. What is the ratio of the Number of enrolments of both sexes in Peru in 1985 to that in 1992?
Ensure brevity in your answer.  0.84. What is the ratio of the Number of enrolments of both sexes of Venezuela in 1985 to that in 1992?
Your response must be concise. 0.84. What is the ratio of the Number of enrolments of both sexes in Cameroon in 1986 to that in 1987?
Your answer should be very brief. 0.88. What is the ratio of the Number of enrolments of both sexes in Guyana in 1986 to that in 1987?
Offer a terse response. 0.99. What is the ratio of the Number of enrolments of both sexes in Peru in 1986 to that in 1987?
Provide a short and direct response. 0.97. What is the ratio of the Number of enrolments of both sexes of Cameroon in 1986 to that in 1989?
Offer a terse response. 0.74. What is the ratio of the Number of enrolments of both sexes of Guyana in 1986 to that in 1989?
Provide a short and direct response. 1.01. What is the ratio of the Number of enrolments of both sexes in Peru in 1986 to that in 1989?
Ensure brevity in your answer.  0.89. What is the ratio of the Number of enrolments of both sexes in Venezuela in 1986 to that in 1989?
Your answer should be compact. 0.95. What is the ratio of the Number of enrolments of both sexes of Cameroon in 1986 to that in 1991?
Your answer should be compact. 0.63. What is the ratio of the Number of enrolments of both sexes in Guyana in 1986 to that in 1991?
Your response must be concise. 1.04. What is the ratio of the Number of enrolments of both sexes in Peru in 1986 to that in 1991?
Provide a succinct answer. 0.86. What is the ratio of the Number of enrolments of both sexes in Venezuela in 1986 to that in 1991?
Your answer should be compact. 0.9. What is the ratio of the Number of enrolments of both sexes of Cameroon in 1986 to that in 1992?
Provide a succinct answer. 0.58. What is the ratio of the Number of enrolments of both sexes of Guyana in 1986 to that in 1992?
Your answer should be very brief. 1.12. What is the ratio of the Number of enrolments of both sexes of Peru in 1986 to that in 1992?
Ensure brevity in your answer.  0.87. What is the ratio of the Number of enrolments of both sexes of Venezuela in 1986 to that in 1992?
Keep it short and to the point. 0.87. What is the ratio of the Number of enrolments of both sexes in Cameroon in 1987 to that in 1989?
Offer a terse response. 0.84. What is the ratio of the Number of enrolments of both sexes of Guyana in 1987 to that in 1989?
Keep it short and to the point. 1.02. What is the ratio of the Number of enrolments of both sexes in Peru in 1987 to that in 1989?
Offer a terse response. 0.92. What is the ratio of the Number of enrolments of both sexes of Venezuela in 1987 to that in 1989?
Ensure brevity in your answer.  0.97. What is the ratio of the Number of enrolments of both sexes in Cameroon in 1987 to that in 1991?
Offer a terse response. 0.71. What is the ratio of the Number of enrolments of both sexes in Guyana in 1987 to that in 1991?
Keep it short and to the point. 1.05. What is the ratio of the Number of enrolments of both sexes of Peru in 1987 to that in 1991?
Make the answer very short. 0.89. What is the ratio of the Number of enrolments of both sexes of Venezuela in 1987 to that in 1991?
Your answer should be very brief. 0.92. What is the ratio of the Number of enrolments of both sexes of Cameroon in 1987 to that in 1992?
Make the answer very short. 0.66. What is the ratio of the Number of enrolments of both sexes in Guyana in 1987 to that in 1992?
Your answer should be compact. 1.13. What is the ratio of the Number of enrolments of both sexes of Peru in 1987 to that in 1992?
Your answer should be very brief. 0.9. What is the ratio of the Number of enrolments of both sexes of Venezuela in 1987 to that in 1992?
Make the answer very short. 0.88. What is the ratio of the Number of enrolments of both sexes of Cameroon in 1989 to that in 1991?
Give a very brief answer. 0.84. What is the ratio of the Number of enrolments of both sexes in Guyana in 1989 to that in 1991?
Your answer should be compact. 1.03. What is the ratio of the Number of enrolments of both sexes in Peru in 1989 to that in 1991?
Ensure brevity in your answer.  0.97. What is the ratio of the Number of enrolments of both sexes of Venezuela in 1989 to that in 1991?
Offer a terse response. 0.95. What is the ratio of the Number of enrolments of both sexes in Cameroon in 1989 to that in 1992?
Offer a terse response. 0.78. What is the ratio of the Number of enrolments of both sexes of Guyana in 1989 to that in 1992?
Your response must be concise. 1.11. What is the ratio of the Number of enrolments of both sexes in Peru in 1989 to that in 1992?
Your answer should be very brief. 0.97. What is the ratio of the Number of enrolments of both sexes of Venezuela in 1989 to that in 1992?
Keep it short and to the point. 0.91. What is the ratio of the Number of enrolments of both sexes in Cameroon in 1991 to that in 1992?
Keep it short and to the point. 0.92. What is the ratio of the Number of enrolments of both sexes in Guyana in 1991 to that in 1992?
Give a very brief answer. 1.07. What is the ratio of the Number of enrolments of both sexes of Peru in 1991 to that in 1992?
Give a very brief answer. 1. What is the ratio of the Number of enrolments of both sexes of Venezuela in 1991 to that in 1992?
Your answer should be very brief. 0.96. What is the difference between the highest and the second highest Number of enrolments of both sexes in Cameroon?
Give a very brief answer. 3.35e+04. What is the difference between the highest and the second highest Number of enrolments of both sexes in Guyana?
Make the answer very short. 739. What is the difference between the highest and the second highest Number of enrolments of both sexes in Peru?
Give a very brief answer. 6718. What is the difference between the highest and the second highest Number of enrolments of both sexes of Venezuela?
Provide a succinct answer. 4.64e+04. What is the difference between the highest and the lowest Number of enrolments of both sexes of Cameroon?
Provide a short and direct response. 2.25e+05. What is the difference between the highest and the lowest Number of enrolments of both sexes of Guyana?
Your answer should be compact. 8900. What is the difference between the highest and the lowest Number of enrolments of both sexes of Peru?
Ensure brevity in your answer.  3.36e+05. What is the difference between the highest and the lowest Number of enrolments of both sexes of Venezuela?
Give a very brief answer. 2.34e+05. 